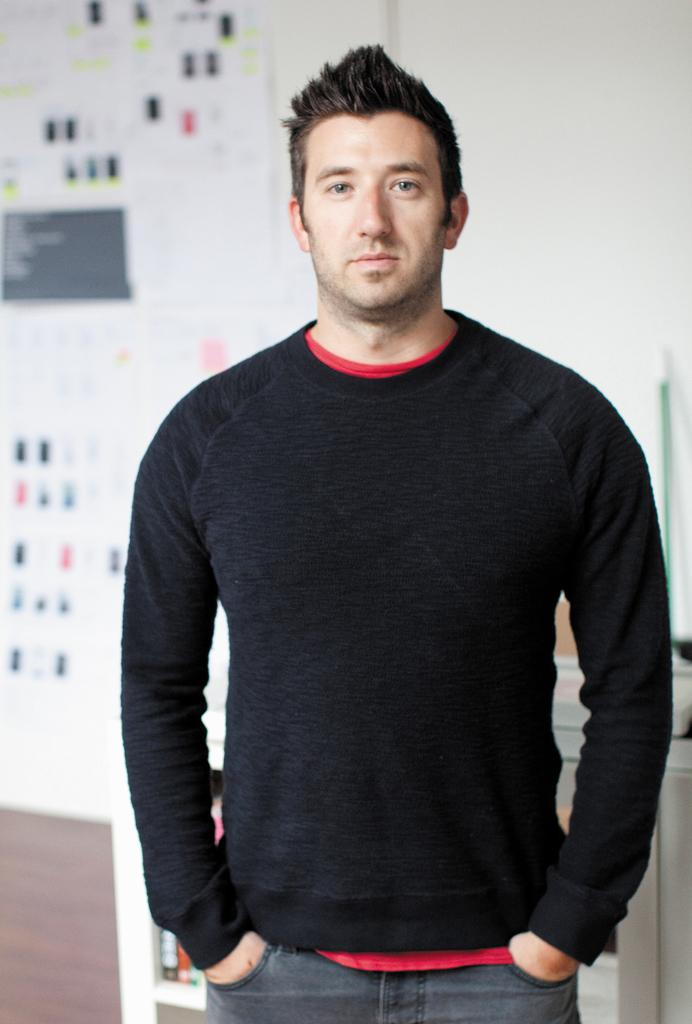What is the main subject of the image? There is a man in the image. What is the man doing in the image? The man is standing. What can be seen in the background of the image? There are posts on a wall in the background of the image. What type of stamp is the man holding in the image? There is no stamp present in the image; the man is simply standing. What is the name of the man's parent in the image? There is no information about the man's parent in the image, nor is there any indication that a parent is present. 